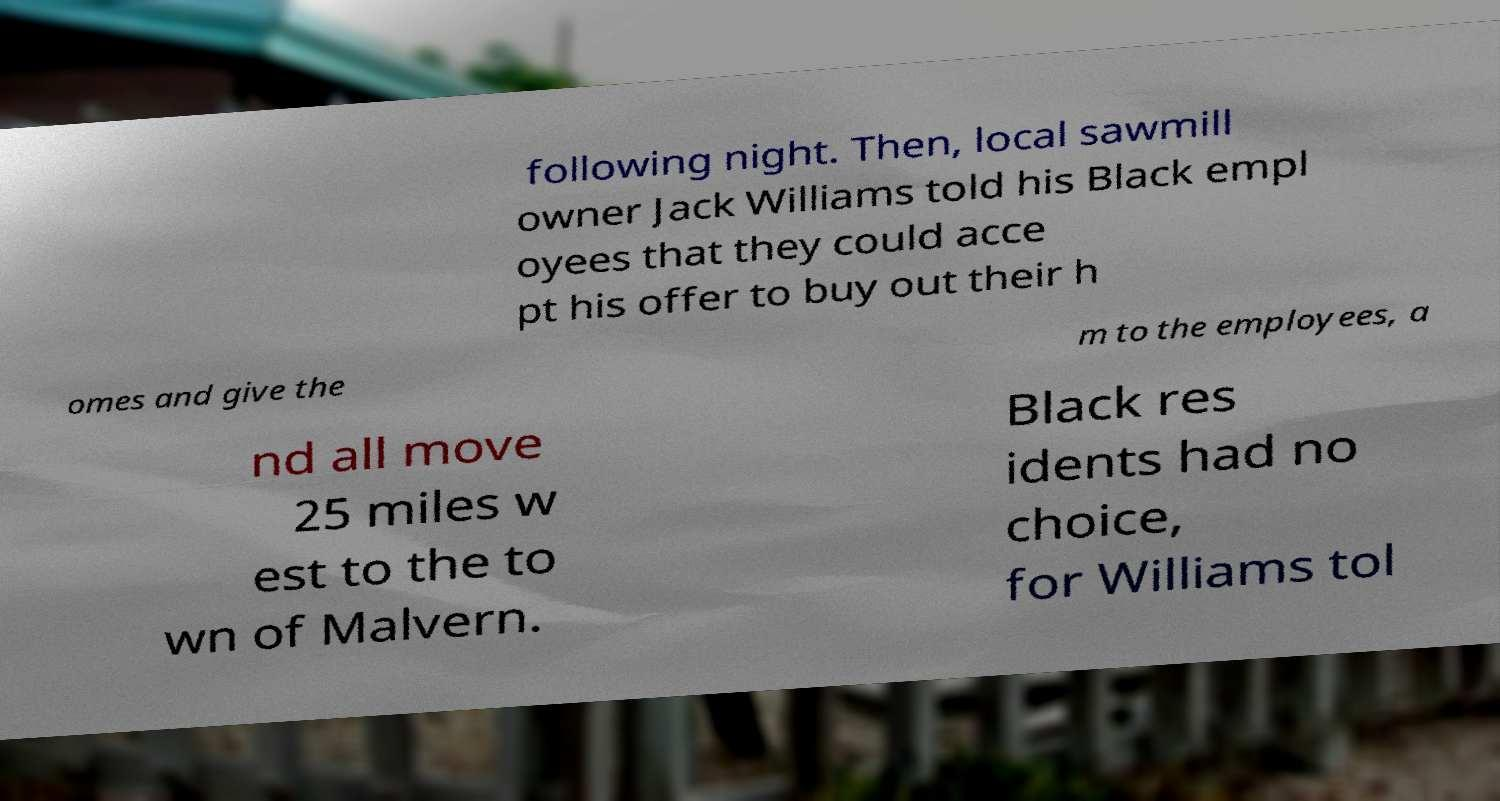Can you accurately transcribe the text from the provided image for me? following night. Then, local sawmill owner Jack Williams told his Black empl oyees that they could acce pt his offer to buy out their h omes and give the m to the employees, a nd all move 25 miles w est to the to wn of Malvern. Black res idents had no choice, for Williams tol 